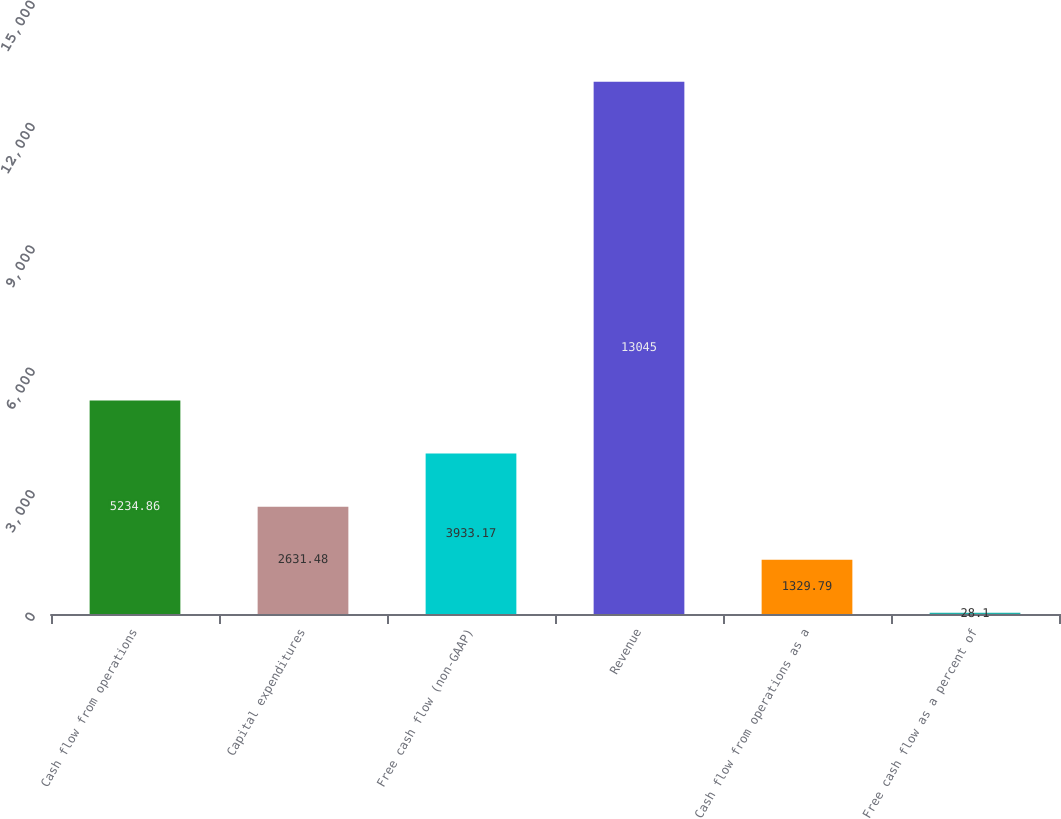Convert chart to OTSL. <chart><loc_0><loc_0><loc_500><loc_500><bar_chart><fcel>Cash flow from operations<fcel>Capital expenditures<fcel>Free cash flow (non-GAAP)<fcel>Revenue<fcel>Cash flow from operations as a<fcel>Free cash flow as a percent of<nl><fcel>5234.86<fcel>2631.48<fcel>3933.17<fcel>13045<fcel>1329.79<fcel>28.1<nl></chart> 